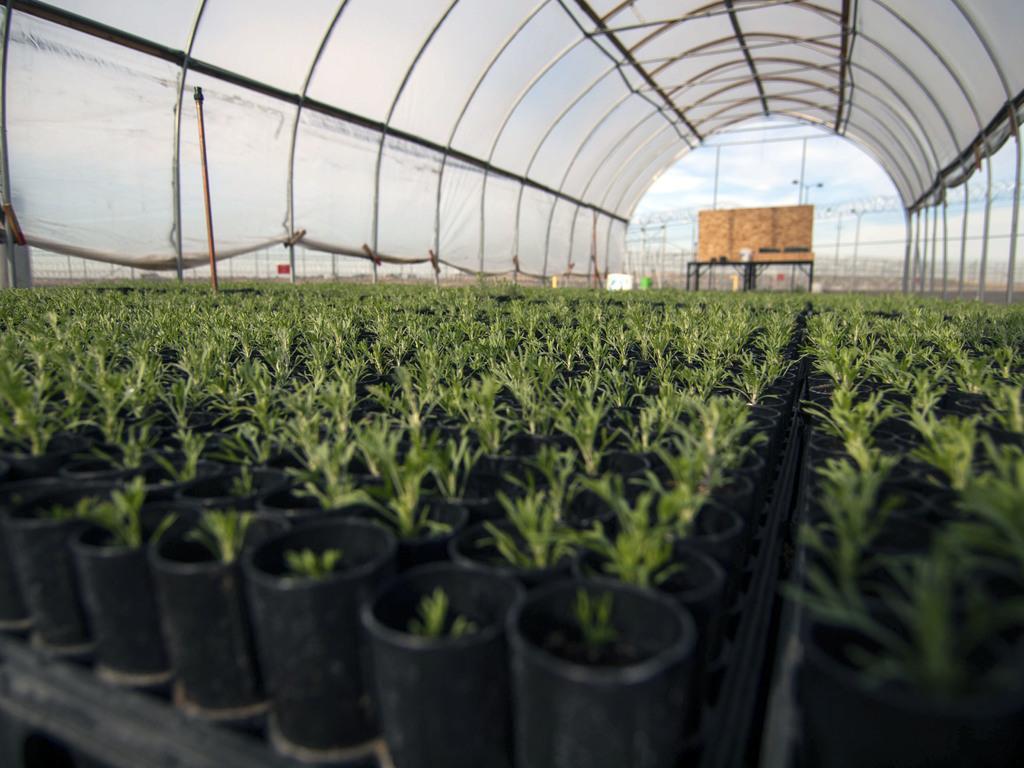Describe this image in one or two sentences. In the picture we can see a house plants placed in the pots which are black in color under the shed which is white in color and in the background we can see some table with a wooden plank on it. 